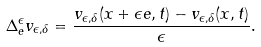<formula> <loc_0><loc_0><loc_500><loc_500>\Delta _ { e } ^ { \epsilon } v _ { \epsilon , \delta } = \frac { v _ { \epsilon , \delta } ( x + \epsilon e , t ) - v _ { \epsilon , \delta } ( x , t ) } { \epsilon } .</formula> 